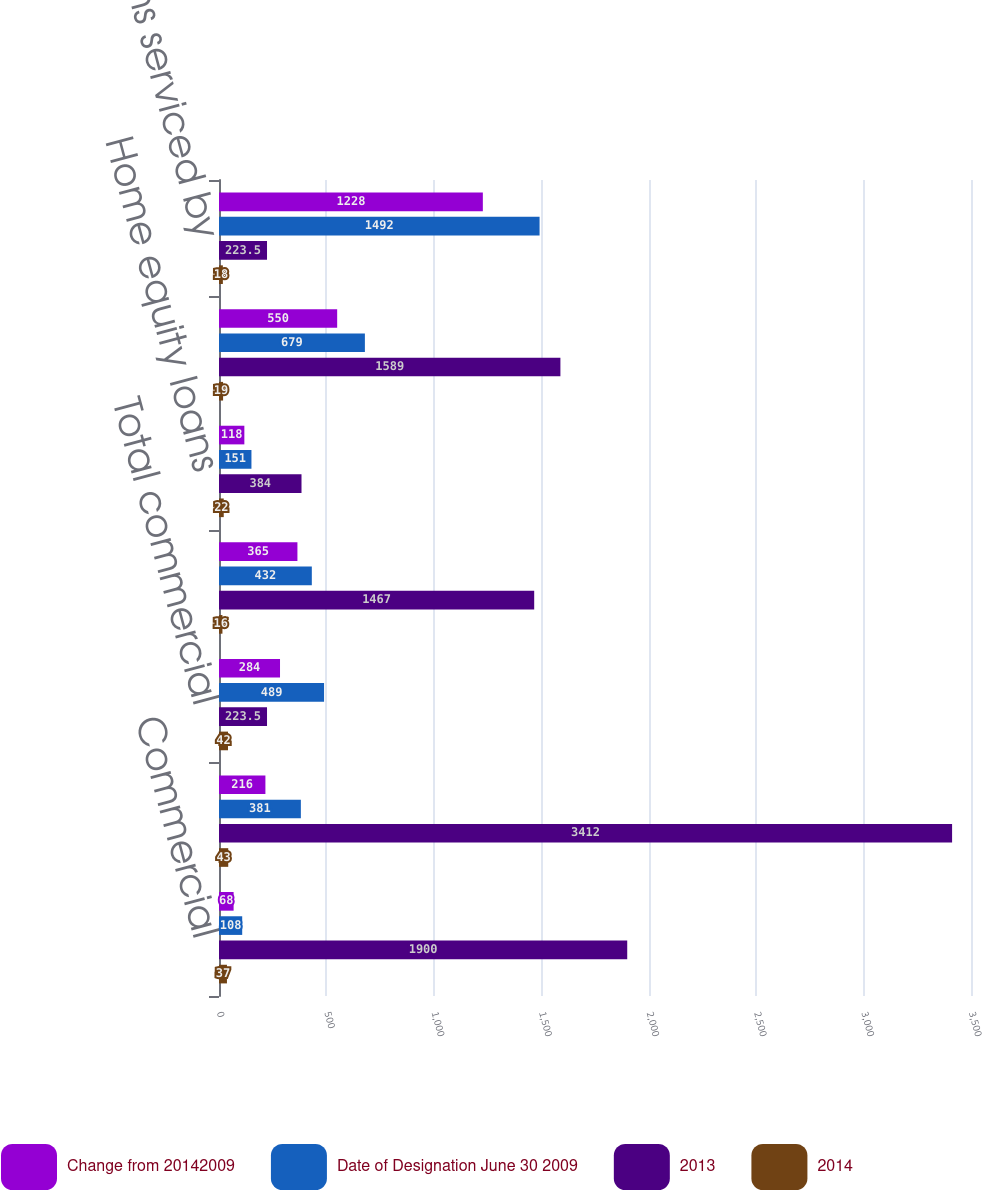Convert chart to OTSL. <chart><loc_0><loc_0><loc_500><loc_500><stacked_bar_chart><ecel><fcel>Commercial<fcel>Commercial real estate<fcel>Total commercial<fcel>Residential mortgages<fcel>Home equity loans<fcel>Home equity lines of credit<fcel>Home equity loans serviced by<nl><fcel>Change from 20142009<fcel>68<fcel>216<fcel>284<fcel>365<fcel>118<fcel>550<fcel>1228<nl><fcel>Date of Designation June 30 2009<fcel>108<fcel>381<fcel>489<fcel>432<fcel>151<fcel>679<fcel>1492<nl><fcel>2013<fcel>1900<fcel>3412<fcel>223.5<fcel>1467<fcel>384<fcel>1589<fcel>223.5<nl><fcel>2014<fcel>37<fcel>43<fcel>42<fcel>16<fcel>22<fcel>19<fcel>18<nl></chart> 